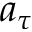<formula> <loc_0><loc_0><loc_500><loc_500>a _ { \tau }</formula> 